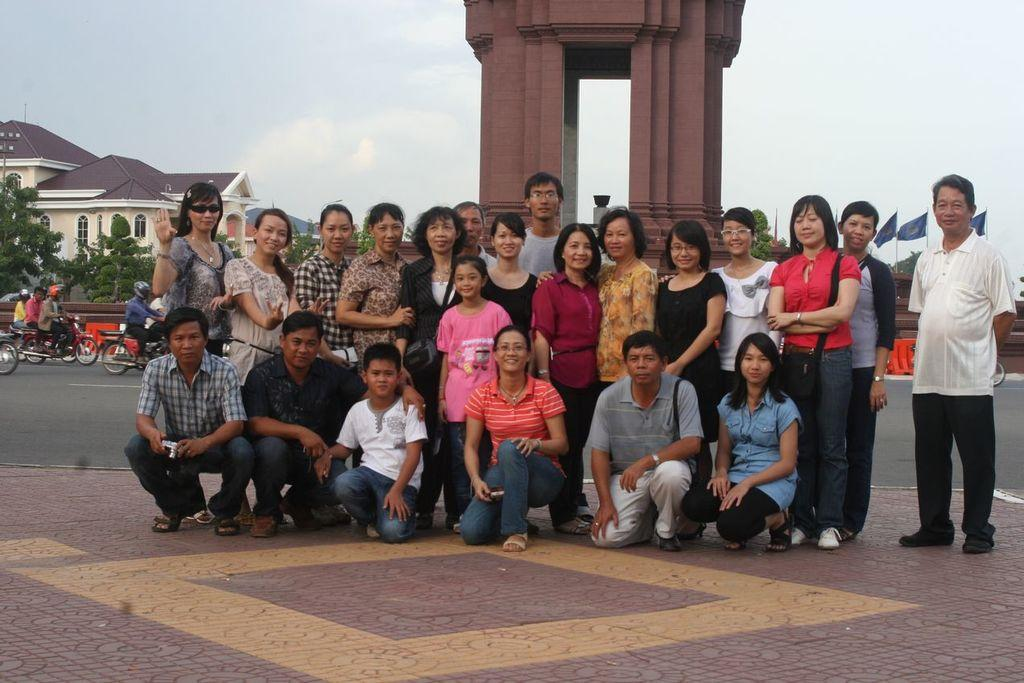What is happening in the image with the group of people? The group of men and women is giving a pose for the camera. What can be seen in the background of the image? There is a shed, houses, and a brown color arch in the background of the image. How many sisters are present in the image? There is no mention of a sister in the image, so it cannot be determined from the facts provided. Are there any horses visible in the image? There are no horses present in the image; the background features a shed, houses, and a brown arch. 